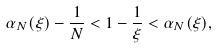Convert formula to latex. <formula><loc_0><loc_0><loc_500><loc_500>\alpha _ { N } ( \xi ) - \frac { 1 } { N } < 1 - \frac { 1 } { \xi } < \alpha _ { N } ( \xi ) ,</formula> 